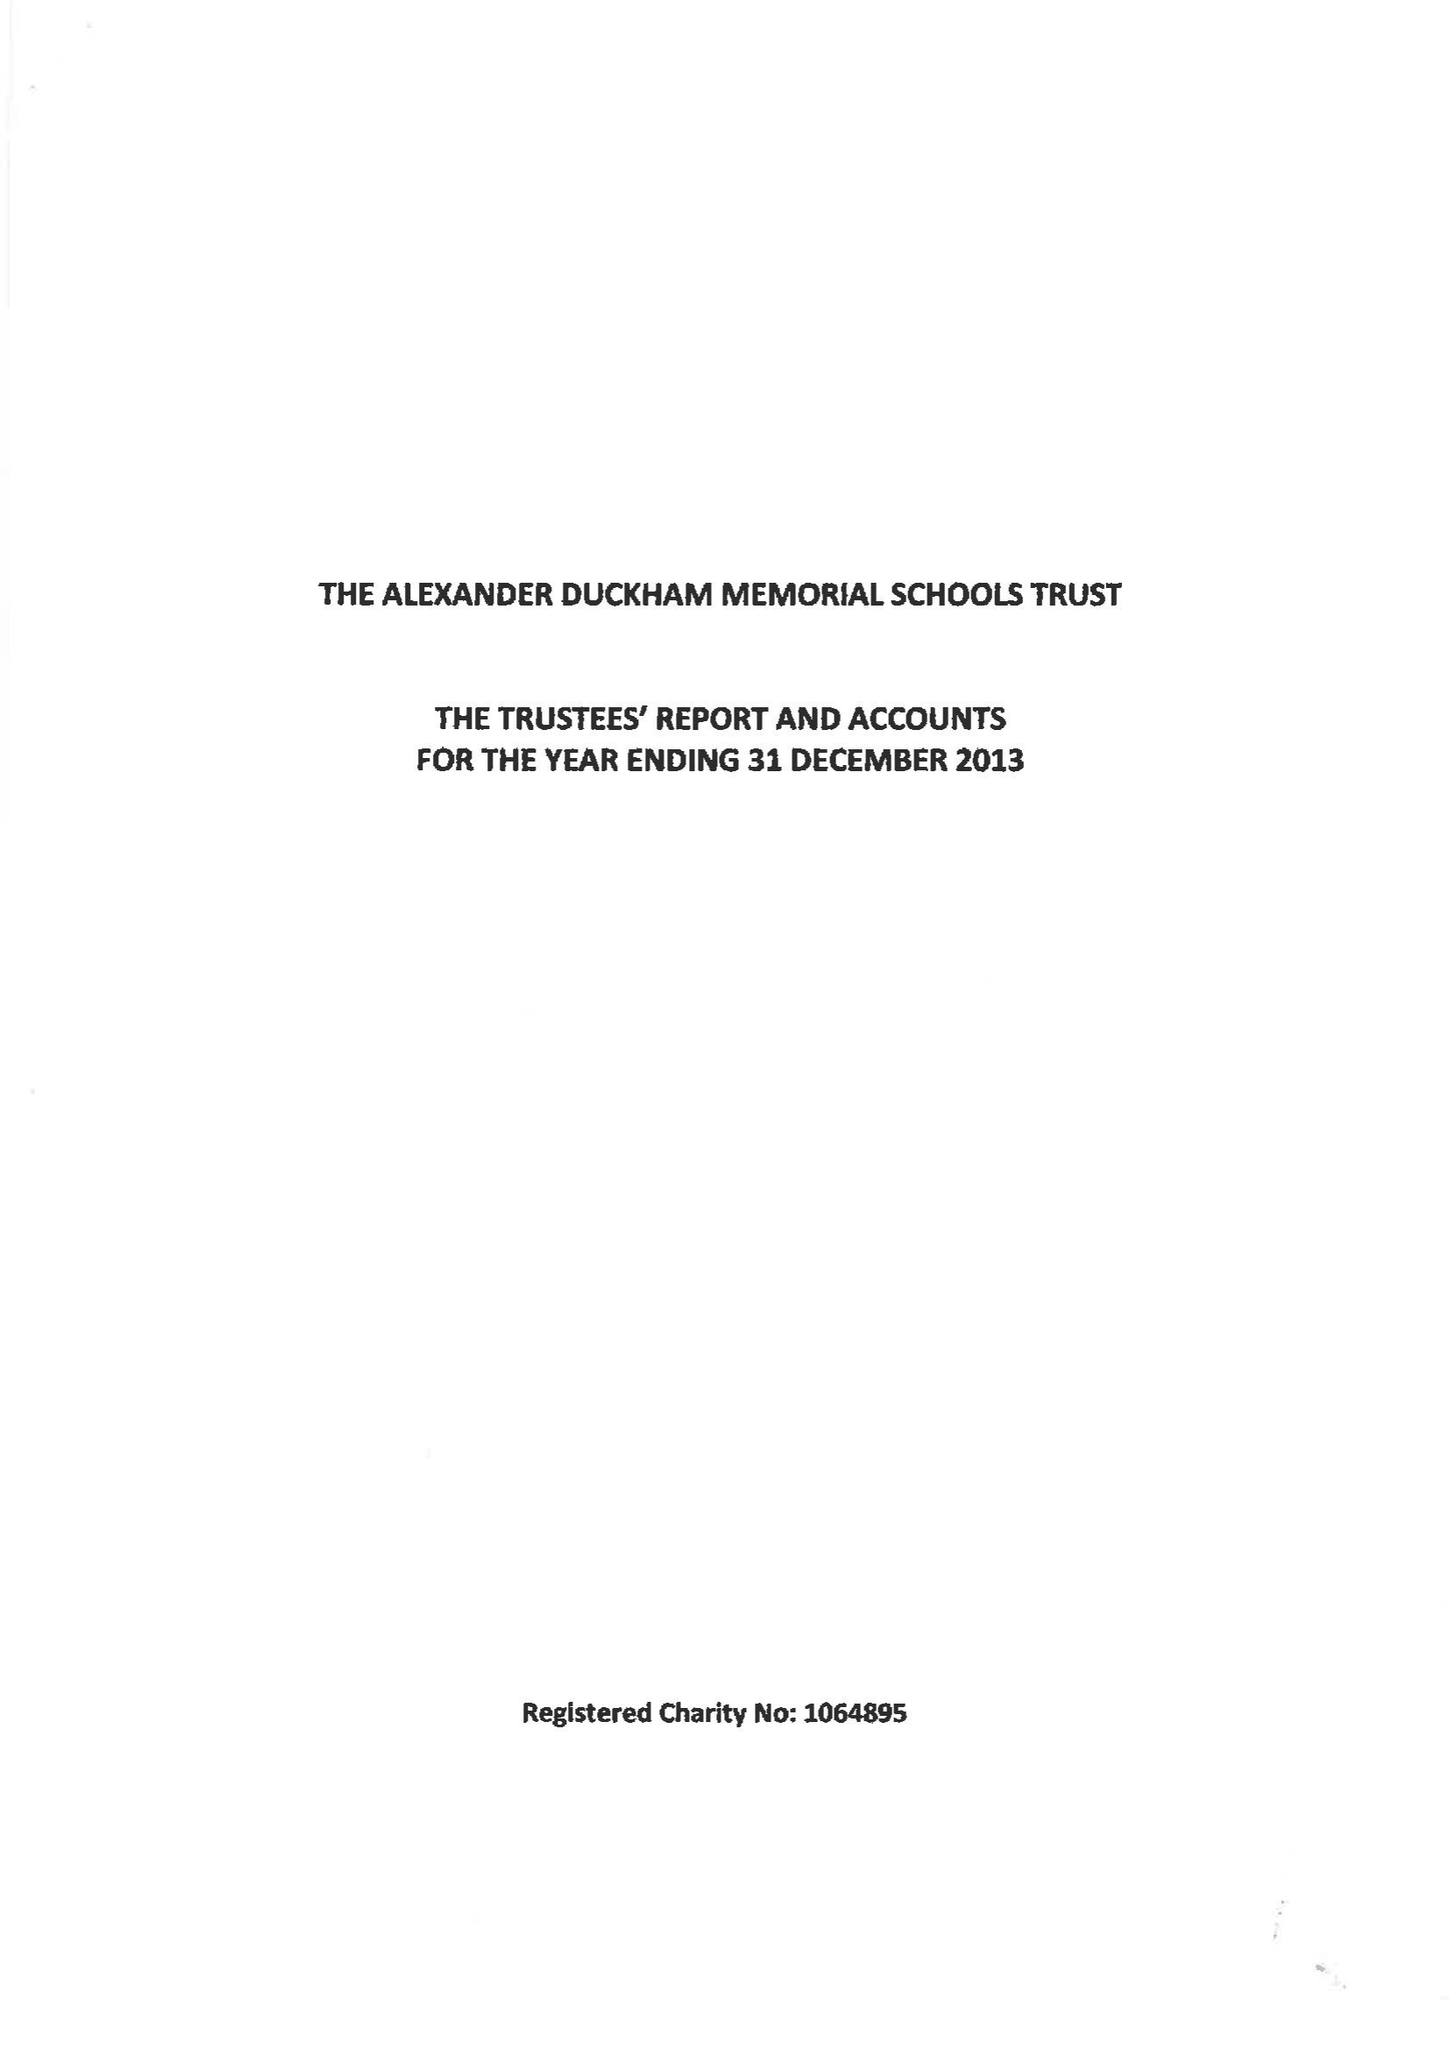What is the value for the charity_number?
Answer the question using a single word or phrase. 1064895 